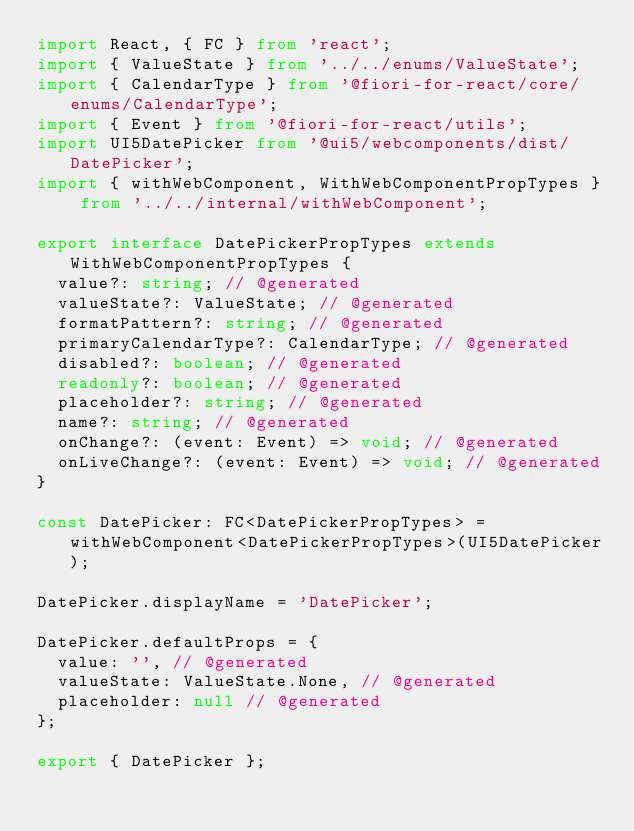Convert code to text. <code><loc_0><loc_0><loc_500><loc_500><_TypeScript_>import React, { FC } from 'react';
import { ValueState } from '../../enums/ValueState';
import { CalendarType } from '@fiori-for-react/core/enums/CalendarType';
import { Event } from '@fiori-for-react/utils';
import UI5DatePicker from '@ui5/webcomponents/dist/DatePicker';
import { withWebComponent, WithWebComponentPropTypes } from '../../internal/withWebComponent';

export interface DatePickerPropTypes extends WithWebComponentPropTypes {
  value?: string; // @generated
  valueState?: ValueState; // @generated
  formatPattern?: string; // @generated
  primaryCalendarType?: CalendarType; // @generated
  disabled?: boolean; // @generated
  readonly?: boolean; // @generated
  placeholder?: string; // @generated
  name?: string; // @generated
  onChange?: (event: Event) => void; // @generated
  onLiveChange?: (event: Event) => void; // @generated
}

const DatePicker: FC<DatePickerPropTypes> = withWebComponent<DatePickerPropTypes>(UI5DatePicker);

DatePicker.displayName = 'DatePicker';

DatePicker.defaultProps = {
  value: '', // @generated
  valueState: ValueState.None, // @generated
  placeholder: null // @generated
};

export { DatePicker };
</code> 